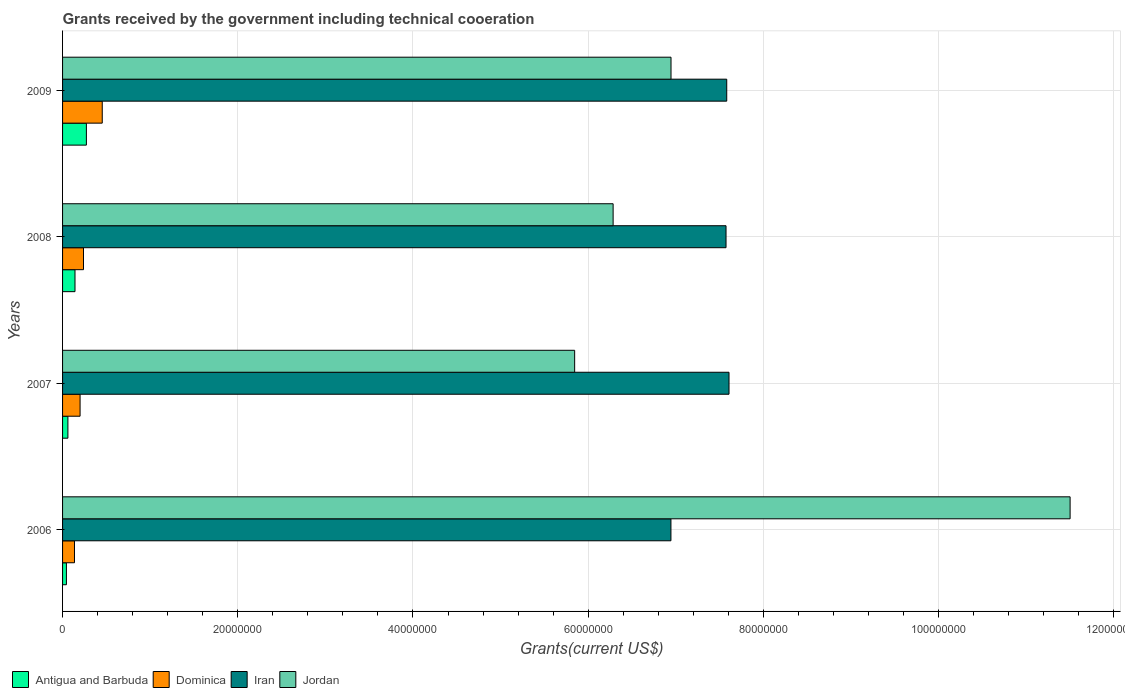How many different coloured bars are there?
Give a very brief answer. 4. Are the number of bars on each tick of the Y-axis equal?
Your answer should be very brief. Yes. How many bars are there on the 2nd tick from the top?
Offer a terse response. 4. How many bars are there on the 2nd tick from the bottom?
Provide a succinct answer. 4. What is the label of the 2nd group of bars from the top?
Your answer should be very brief. 2008. In how many cases, is the number of bars for a given year not equal to the number of legend labels?
Offer a very short reply. 0. What is the total grants received by the government in Iran in 2007?
Your answer should be compact. 7.61e+07. Across all years, what is the maximum total grants received by the government in Iran?
Your response must be concise. 7.61e+07. Across all years, what is the minimum total grants received by the government in Iran?
Keep it short and to the point. 6.94e+07. What is the total total grants received by the government in Jordan in the graph?
Provide a succinct answer. 3.06e+08. What is the difference between the total grants received by the government in Iran in 2006 and that in 2009?
Your response must be concise. -6.37e+06. What is the difference between the total grants received by the government in Jordan in 2006 and the total grants received by the government in Dominica in 2008?
Keep it short and to the point. 1.13e+08. What is the average total grants received by the government in Antigua and Barbuda per year?
Make the answer very short. 1.30e+06. In the year 2008, what is the difference between the total grants received by the government in Antigua and Barbuda and total grants received by the government in Jordan?
Your answer should be very brief. -6.14e+07. In how many years, is the total grants received by the government in Dominica greater than 48000000 US$?
Provide a short and direct response. 0. What is the ratio of the total grants received by the government in Jordan in 2006 to that in 2008?
Your answer should be very brief. 1.83. Is the difference between the total grants received by the government in Antigua and Barbuda in 2007 and 2008 greater than the difference between the total grants received by the government in Jordan in 2007 and 2008?
Your answer should be compact. Yes. What is the difference between the highest and the second highest total grants received by the government in Dominica?
Make the answer very short. 2.14e+06. What is the difference between the highest and the lowest total grants received by the government in Iran?
Offer a very short reply. 6.63e+06. Is it the case that in every year, the sum of the total grants received by the government in Iran and total grants received by the government in Jordan is greater than the sum of total grants received by the government in Antigua and Barbuda and total grants received by the government in Dominica?
Offer a very short reply. Yes. What does the 3rd bar from the top in 2009 represents?
Give a very brief answer. Dominica. What does the 1st bar from the bottom in 2006 represents?
Offer a very short reply. Antigua and Barbuda. How many years are there in the graph?
Keep it short and to the point. 4. Are the values on the major ticks of X-axis written in scientific E-notation?
Provide a short and direct response. No. Does the graph contain any zero values?
Keep it short and to the point. No. Does the graph contain grids?
Provide a succinct answer. Yes. Where does the legend appear in the graph?
Provide a succinct answer. Bottom left. How many legend labels are there?
Give a very brief answer. 4. How are the legend labels stacked?
Ensure brevity in your answer.  Horizontal. What is the title of the graph?
Provide a short and direct response. Grants received by the government including technical cooeration. What is the label or title of the X-axis?
Keep it short and to the point. Grants(current US$). What is the label or title of the Y-axis?
Your answer should be compact. Years. What is the Grants(current US$) in Dominica in 2006?
Offer a very short reply. 1.36e+06. What is the Grants(current US$) of Iran in 2006?
Ensure brevity in your answer.  6.94e+07. What is the Grants(current US$) in Jordan in 2006?
Provide a succinct answer. 1.15e+08. What is the Grants(current US$) of Antigua and Barbuda in 2007?
Make the answer very short. 6.10e+05. What is the Grants(current US$) in Dominica in 2007?
Keep it short and to the point. 2.00e+06. What is the Grants(current US$) in Iran in 2007?
Your answer should be compact. 7.61e+07. What is the Grants(current US$) in Jordan in 2007?
Your answer should be compact. 5.85e+07. What is the Grants(current US$) of Antigua and Barbuda in 2008?
Give a very brief answer. 1.42e+06. What is the Grants(current US$) of Dominica in 2008?
Your answer should be very brief. 2.39e+06. What is the Grants(current US$) in Iran in 2008?
Give a very brief answer. 7.57e+07. What is the Grants(current US$) of Jordan in 2008?
Make the answer very short. 6.28e+07. What is the Grants(current US$) in Antigua and Barbuda in 2009?
Make the answer very short. 2.72e+06. What is the Grants(current US$) of Dominica in 2009?
Provide a short and direct response. 4.53e+06. What is the Grants(current US$) of Iran in 2009?
Ensure brevity in your answer.  7.58e+07. What is the Grants(current US$) in Jordan in 2009?
Provide a short and direct response. 6.95e+07. Across all years, what is the maximum Grants(current US$) of Antigua and Barbuda?
Ensure brevity in your answer.  2.72e+06. Across all years, what is the maximum Grants(current US$) of Dominica?
Provide a short and direct response. 4.53e+06. Across all years, what is the maximum Grants(current US$) in Iran?
Ensure brevity in your answer.  7.61e+07. Across all years, what is the maximum Grants(current US$) in Jordan?
Ensure brevity in your answer.  1.15e+08. Across all years, what is the minimum Grants(current US$) of Dominica?
Give a very brief answer. 1.36e+06. Across all years, what is the minimum Grants(current US$) of Iran?
Ensure brevity in your answer.  6.94e+07. Across all years, what is the minimum Grants(current US$) in Jordan?
Your response must be concise. 5.85e+07. What is the total Grants(current US$) of Antigua and Barbuda in the graph?
Your response must be concise. 5.19e+06. What is the total Grants(current US$) in Dominica in the graph?
Your answer should be very brief. 1.03e+07. What is the total Grants(current US$) of Iran in the graph?
Keep it short and to the point. 2.97e+08. What is the total Grants(current US$) of Jordan in the graph?
Your response must be concise. 3.06e+08. What is the difference between the Grants(current US$) of Antigua and Barbuda in 2006 and that in 2007?
Give a very brief answer. -1.70e+05. What is the difference between the Grants(current US$) in Dominica in 2006 and that in 2007?
Give a very brief answer. -6.40e+05. What is the difference between the Grants(current US$) of Iran in 2006 and that in 2007?
Offer a terse response. -6.63e+06. What is the difference between the Grants(current US$) of Jordan in 2006 and that in 2007?
Offer a very short reply. 5.66e+07. What is the difference between the Grants(current US$) of Antigua and Barbuda in 2006 and that in 2008?
Keep it short and to the point. -9.80e+05. What is the difference between the Grants(current US$) in Dominica in 2006 and that in 2008?
Give a very brief answer. -1.03e+06. What is the difference between the Grants(current US$) of Iran in 2006 and that in 2008?
Your answer should be compact. -6.29e+06. What is the difference between the Grants(current US$) in Jordan in 2006 and that in 2008?
Keep it short and to the point. 5.22e+07. What is the difference between the Grants(current US$) of Antigua and Barbuda in 2006 and that in 2009?
Give a very brief answer. -2.28e+06. What is the difference between the Grants(current US$) in Dominica in 2006 and that in 2009?
Offer a terse response. -3.17e+06. What is the difference between the Grants(current US$) in Iran in 2006 and that in 2009?
Your response must be concise. -6.37e+06. What is the difference between the Grants(current US$) in Jordan in 2006 and that in 2009?
Provide a succinct answer. 4.56e+07. What is the difference between the Grants(current US$) in Antigua and Barbuda in 2007 and that in 2008?
Offer a very short reply. -8.10e+05. What is the difference between the Grants(current US$) in Dominica in 2007 and that in 2008?
Give a very brief answer. -3.90e+05. What is the difference between the Grants(current US$) of Jordan in 2007 and that in 2008?
Make the answer very short. -4.39e+06. What is the difference between the Grants(current US$) in Antigua and Barbuda in 2007 and that in 2009?
Your response must be concise. -2.11e+06. What is the difference between the Grants(current US$) in Dominica in 2007 and that in 2009?
Provide a short and direct response. -2.53e+06. What is the difference between the Grants(current US$) of Jordan in 2007 and that in 2009?
Offer a terse response. -1.10e+07. What is the difference between the Grants(current US$) in Antigua and Barbuda in 2008 and that in 2009?
Provide a succinct answer. -1.30e+06. What is the difference between the Grants(current US$) of Dominica in 2008 and that in 2009?
Give a very brief answer. -2.14e+06. What is the difference between the Grants(current US$) of Iran in 2008 and that in 2009?
Give a very brief answer. -8.00e+04. What is the difference between the Grants(current US$) in Jordan in 2008 and that in 2009?
Offer a terse response. -6.61e+06. What is the difference between the Grants(current US$) of Antigua and Barbuda in 2006 and the Grants(current US$) of Dominica in 2007?
Provide a short and direct response. -1.56e+06. What is the difference between the Grants(current US$) of Antigua and Barbuda in 2006 and the Grants(current US$) of Iran in 2007?
Your answer should be compact. -7.56e+07. What is the difference between the Grants(current US$) in Antigua and Barbuda in 2006 and the Grants(current US$) in Jordan in 2007?
Keep it short and to the point. -5.80e+07. What is the difference between the Grants(current US$) in Dominica in 2006 and the Grants(current US$) in Iran in 2007?
Offer a terse response. -7.47e+07. What is the difference between the Grants(current US$) of Dominica in 2006 and the Grants(current US$) of Jordan in 2007?
Ensure brevity in your answer.  -5.71e+07. What is the difference between the Grants(current US$) in Iran in 2006 and the Grants(current US$) in Jordan in 2007?
Your answer should be compact. 1.10e+07. What is the difference between the Grants(current US$) of Antigua and Barbuda in 2006 and the Grants(current US$) of Dominica in 2008?
Make the answer very short. -1.95e+06. What is the difference between the Grants(current US$) of Antigua and Barbuda in 2006 and the Grants(current US$) of Iran in 2008?
Offer a very short reply. -7.53e+07. What is the difference between the Grants(current US$) of Antigua and Barbuda in 2006 and the Grants(current US$) of Jordan in 2008?
Provide a succinct answer. -6.24e+07. What is the difference between the Grants(current US$) of Dominica in 2006 and the Grants(current US$) of Iran in 2008?
Your answer should be very brief. -7.44e+07. What is the difference between the Grants(current US$) of Dominica in 2006 and the Grants(current US$) of Jordan in 2008?
Provide a succinct answer. -6.15e+07. What is the difference between the Grants(current US$) of Iran in 2006 and the Grants(current US$) of Jordan in 2008?
Keep it short and to the point. 6.60e+06. What is the difference between the Grants(current US$) in Antigua and Barbuda in 2006 and the Grants(current US$) in Dominica in 2009?
Your answer should be very brief. -4.09e+06. What is the difference between the Grants(current US$) in Antigua and Barbuda in 2006 and the Grants(current US$) in Iran in 2009?
Provide a succinct answer. -7.54e+07. What is the difference between the Grants(current US$) in Antigua and Barbuda in 2006 and the Grants(current US$) in Jordan in 2009?
Your answer should be very brief. -6.90e+07. What is the difference between the Grants(current US$) in Dominica in 2006 and the Grants(current US$) in Iran in 2009?
Provide a short and direct response. -7.45e+07. What is the difference between the Grants(current US$) of Dominica in 2006 and the Grants(current US$) of Jordan in 2009?
Ensure brevity in your answer.  -6.81e+07. What is the difference between the Grants(current US$) of Antigua and Barbuda in 2007 and the Grants(current US$) of Dominica in 2008?
Your answer should be compact. -1.78e+06. What is the difference between the Grants(current US$) in Antigua and Barbuda in 2007 and the Grants(current US$) in Iran in 2008?
Keep it short and to the point. -7.51e+07. What is the difference between the Grants(current US$) in Antigua and Barbuda in 2007 and the Grants(current US$) in Jordan in 2008?
Provide a succinct answer. -6.22e+07. What is the difference between the Grants(current US$) of Dominica in 2007 and the Grants(current US$) of Iran in 2008?
Your response must be concise. -7.37e+07. What is the difference between the Grants(current US$) in Dominica in 2007 and the Grants(current US$) in Jordan in 2008?
Make the answer very short. -6.08e+07. What is the difference between the Grants(current US$) of Iran in 2007 and the Grants(current US$) of Jordan in 2008?
Your response must be concise. 1.32e+07. What is the difference between the Grants(current US$) of Antigua and Barbuda in 2007 and the Grants(current US$) of Dominica in 2009?
Offer a very short reply. -3.92e+06. What is the difference between the Grants(current US$) of Antigua and Barbuda in 2007 and the Grants(current US$) of Iran in 2009?
Provide a short and direct response. -7.52e+07. What is the difference between the Grants(current US$) in Antigua and Barbuda in 2007 and the Grants(current US$) in Jordan in 2009?
Offer a terse response. -6.88e+07. What is the difference between the Grants(current US$) in Dominica in 2007 and the Grants(current US$) in Iran in 2009?
Make the answer very short. -7.38e+07. What is the difference between the Grants(current US$) of Dominica in 2007 and the Grants(current US$) of Jordan in 2009?
Your response must be concise. -6.75e+07. What is the difference between the Grants(current US$) of Iran in 2007 and the Grants(current US$) of Jordan in 2009?
Give a very brief answer. 6.62e+06. What is the difference between the Grants(current US$) in Antigua and Barbuda in 2008 and the Grants(current US$) in Dominica in 2009?
Your answer should be compact. -3.11e+06. What is the difference between the Grants(current US$) in Antigua and Barbuda in 2008 and the Grants(current US$) in Iran in 2009?
Offer a terse response. -7.44e+07. What is the difference between the Grants(current US$) of Antigua and Barbuda in 2008 and the Grants(current US$) of Jordan in 2009?
Your response must be concise. -6.80e+07. What is the difference between the Grants(current US$) of Dominica in 2008 and the Grants(current US$) of Iran in 2009?
Provide a short and direct response. -7.34e+07. What is the difference between the Grants(current US$) in Dominica in 2008 and the Grants(current US$) in Jordan in 2009?
Provide a short and direct response. -6.71e+07. What is the difference between the Grants(current US$) in Iran in 2008 and the Grants(current US$) in Jordan in 2009?
Provide a short and direct response. 6.28e+06. What is the average Grants(current US$) in Antigua and Barbuda per year?
Ensure brevity in your answer.  1.30e+06. What is the average Grants(current US$) of Dominica per year?
Ensure brevity in your answer.  2.57e+06. What is the average Grants(current US$) in Iran per year?
Provide a short and direct response. 7.43e+07. What is the average Grants(current US$) of Jordan per year?
Your response must be concise. 7.64e+07. In the year 2006, what is the difference between the Grants(current US$) in Antigua and Barbuda and Grants(current US$) in Dominica?
Offer a terse response. -9.20e+05. In the year 2006, what is the difference between the Grants(current US$) in Antigua and Barbuda and Grants(current US$) in Iran?
Your answer should be very brief. -6.90e+07. In the year 2006, what is the difference between the Grants(current US$) in Antigua and Barbuda and Grants(current US$) in Jordan?
Keep it short and to the point. -1.15e+08. In the year 2006, what is the difference between the Grants(current US$) in Dominica and Grants(current US$) in Iran?
Keep it short and to the point. -6.81e+07. In the year 2006, what is the difference between the Grants(current US$) of Dominica and Grants(current US$) of Jordan?
Offer a terse response. -1.14e+08. In the year 2006, what is the difference between the Grants(current US$) in Iran and Grants(current US$) in Jordan?
Give a very brief answer. -4.56e+07. In the year 2007, what is the difference between the Grants(current US$) of Antigua and Barbuda and Grants(current US$) of Dominica?
Your answer should be very brief. -1.39e+06. In the year 2007, what is the difference between the Grants(current US$) of Antigua and Barbuda and Grants(current US$) of Iran?
Give a very brief answer. -7.55e+07. In the year 2007, what is the difference between the Grants(current US$) in Antigua and Barbuda and Grants(current US$) in Jordan?
Your response must be concise. -5.78e+07. In the year 2007, what is the difference between the Grants(current US$) of Dominica and Grants(current US$) of Iran?
Provide a succinct answer. -7.41e+07. In the year 2007, what is the difference between the Grants(current US$) in Dominica and Grants(current US$) in Jordan?
Keep it short and to the point. -5.65e+07. In the year 2007, what is the difference between the Grants(current US$) in Iran and Grants(current US$) in Jordan?
Your response must be concise. 1.76e+07. In the year 2008, what is the difference between the Grants(current US$) in Antigua and Barbuda and Grants(current US$) in Dominica?
Keep it short and to the point. -9.70e+05. In the year 2008, what is the difference between the Grants(current US$) of Antigua and Barbuda and Grants(current US$) of Iran?
Offer a very short reply. -7.43e+07. In the year 2008, what is the difference between the Grants(current US$) in Antigua and Barbuda and Grants(current US$) in Jordan?
Provide a short and direct response. -6.14e+07. In the year 2008, what is the difference between the Grants(current US$) of Dominica and Grants(current US$) of Iran?
Give a very brief answer. -7.34e+07. In the year 2008, what is the difference between the Grants(current US$) in Dominica and Grants(current US$) in Jordan?
Provide a short and direct response. -6.05e+07. In the year 2008, what is the difference between the Grants(current US$) of Iran and Grants(current US$) of Jordan?
Provide a succinct answer. 1.29e+07. In the year 2009, what is the difference between the Grants(current US$) in Antigua and Barbuda and Grants(current US$) in Dominica?
Offer a terse response. -1.81e+06. In the year 2009, what is the difference between the Grants(current US$) of Antigua and Barbuda and Grants(current US$) of Iran?
Your response must be concise. -7.31e+07. In the year 2009, what is the difference between the Grants(current US$) of Antigua and Barbuda and Grants(current US$) of Jordan?
Provide a short and direct response. -6.67e+07. In the year 2009, what is the difference between the Grants(current US$) in Dominica and Grants(current US$) in Iran?
Offer a very short reply. -7.13e+07. In the year 2009, what is the difference between the Grants(current US$) in Dominica and Grants(current US$) in Jordan?
Your answer should be compact. -6.49e+07. In the year 2009, what is the difference between the Grants(current US$) of Iran and Grants(current US$) of Jordan?
Offer a very short reply. 6.36e+06. What is the ratio of the Grants(current US$) of Antigua and Barbuda in 2006 to that in 2007?
Provide a succinct answer. 0.72. What is the ratio of the Grants(current US$) of Dominica in 2006 to that in 2007?
Make the answer very short. 0.68. What is the ratio of the Grants(current US$) in Iran in 2006 to that in 2007?
Give a very brief answer. 0.91. What is the ratio of the Grants(current US$) of Jordan in 2006 to that in 2007?
Provide a succinct answer. 1.97. What is the ratio of the Grants(current US$) in Antigua and Barbuda in 2006 to that in 2008?
Offer a terse response. 0.31. What is the ratio of the Grants(current US$) of Dominica in 2006 to that in 2008?
Ensure brevity in your answer.  0.57. What is the ratio of the Grants(current US$) of Iran in 2006 to that in 2008?
Make the answer very short. 0.92. What is the ratio of the Grants(current US$) of Jordan in 2006 to that in 2008?
Provide a succinct answer. 1.83. What is the ratio of the Grants(current US$) in Antigua and Barbuda in 2006 to that in 2009?
Make the answer very short. 0.16. What is the ratio of the Grants(current US$) of Dominica in 2006 to that in 2009?
Provide a short and direct response. 0.3. What is the ratio of the Grants(current US$) in Iran in 2006 to that in 2009?
Give a very brief answer. 0.92. What is the ratio of the Grants(current US$) of Jordan in 2006 to that in 2009?
Your response must be concise. 1.66. What is the ratio of the Grants(current US$) in Antigua and Barbuda in 2007 to that in 2008?
Your answer should be compact. 0.43. What is the ratio of the Grants(current US$) of Dominica in 2007 to that in 2008?
Ensure brevity in your answer.  0.84. What is the ratio of the Grants(current US$) of Iran in 2007 to that in 2008?
Your response must be concise. 1. What is the ratio of the Grants(current US$) of Jordan in 2007 to that in 2008?
Your response must be concise. 0.93. What is the ratio of the Grants(current US$) of Antigua and Barbuda in 2007 to that in 2009?
Make the answer very short. 0.22. What is the ratio of the Grants(current US$) of Dominica in 2007 to that in 2009?
Provide a short and direct response. 0.44. What is the ratio of the Grants(current US$) of Iran in 2007 to that in 2009?
Your answer should be compact. 1. What is the ratio of the Grants(current US$) in Jordan in 2007 to that in 2009?
Ensure brevity in your answer.  0.84. What is the ratio of the Grants(current US$) of Antigua and Barbuda in 2008 to that in 2009?
Ensure brevity in your answer.  0.52. What is the ratio of the Grants(current US$) in Dominica in 2008 to that in 2009?
Keep it short and to the point. 0.53. What is the ratio of the Grants(current US$) in Jordan in 2008 to that in 2009?
Ensure brevity in your answer.  0.9. What is the difference between the highest and the second highest Grants(current US$) of Antigua and Barbuda?
Offer a terse response. 1.30e+06. What is the difference between the highest and the second highest Grants(current US$) of Dominica?
Your response must be concise. 2.14e+06. What is the difference between the highest and the second highest Grants(current US$) of Jordan?
Offer a very short reply. 4.56e+07. What is the difference between the highest and the lowest Grants(current US$) in Antigua and Barbuda?
Your answer should be very brief. 2.28e+06. What is the difference between the highest and the lowest Grants(current US$) in Dominica?
Keep it short and to the point. 3.17e+06. What is the difference between the highest and the lowest Grants(current US$) in Iran?
Your response must be concise. 6.63e+06. What is the difference between the highest and the lowest Grants(current US$) of Jordan?
Keep it short and to the point. 5.66e+07. 